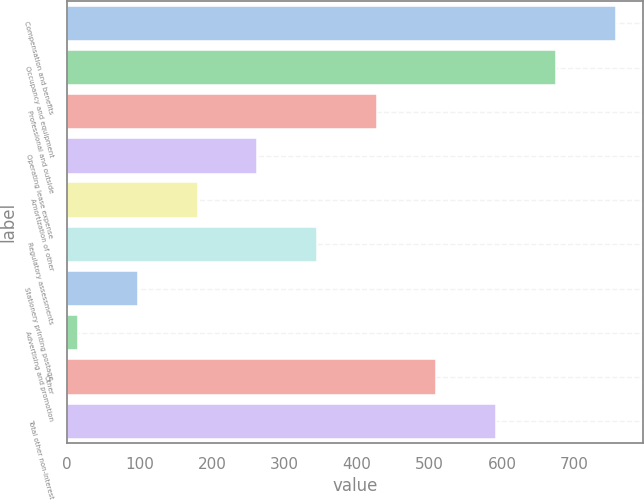<chart> <loc_0><loc_0><loc_500><loc_500><bar_chart><fcel>Compensation and benefits<fcel>Occupancy and equipment<fcel>Professional and outside<fcel>Operating lease expense<fcel>Amortization of other<fcel>Regulatory assessments<fcel>Stationery printing postage<fcel>Advertising and promotion<fcel>Other<fcel>Total other non-interest<nl><fcel>756.64<fcel>674.28<fcel>427.2<fcel>262.48<fcel>180.12<fcel>344.84<fcel>97.76<fcel>15.4<fcel>509.56<fcel>591.92<nl></chart> 